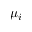Convert formula to latex. <formula><loc_0><loc_0><loc_500><loc_500>\mu _ { i }</formula> 